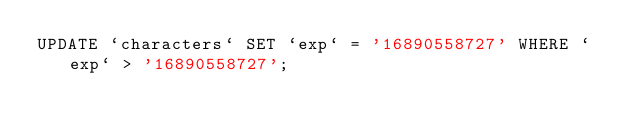<code> <loc_0><loc_0><loc_500><loc_500><_SQL_>UPDATE `characters` SET `exp` = '16890558727' WHERE `exp` > '16890558727';</code> 